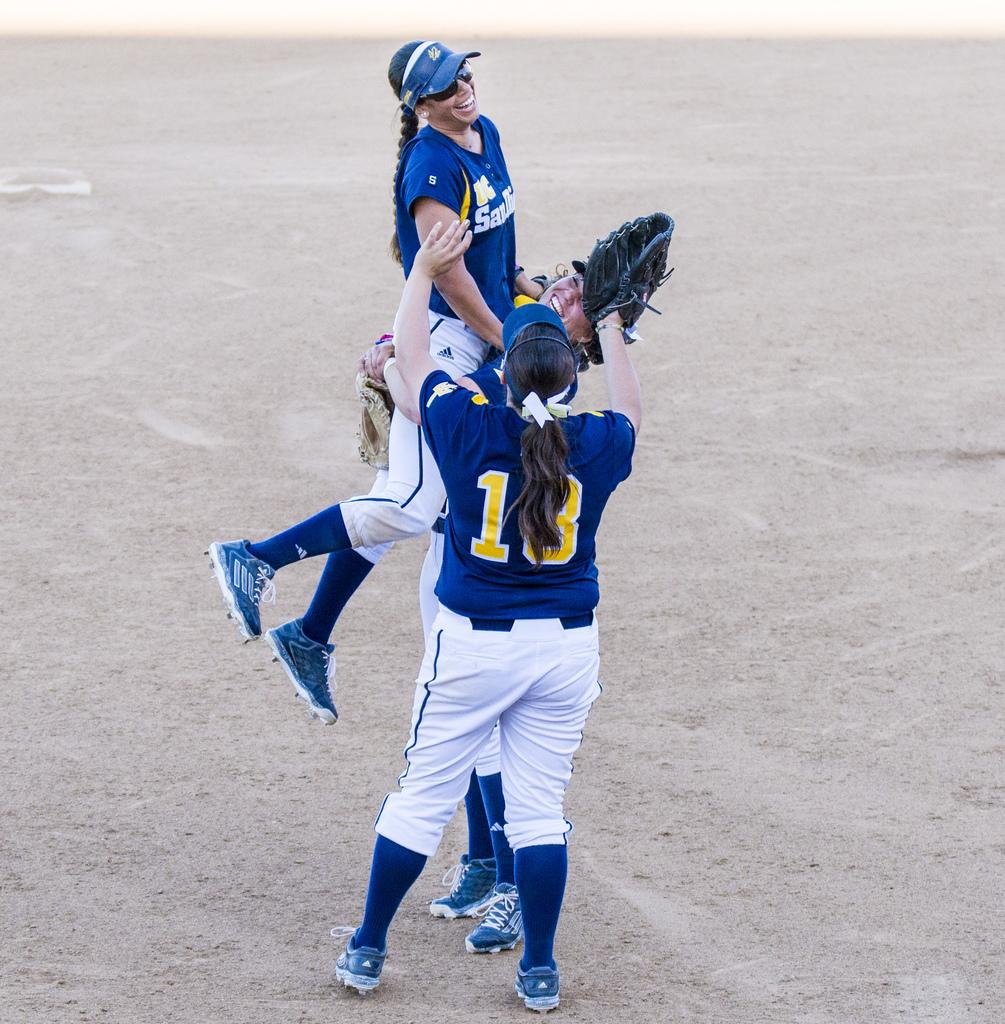<image>
Write a terse but informative summary of the picture. UC San Diego's women's softball team is celebrating. 